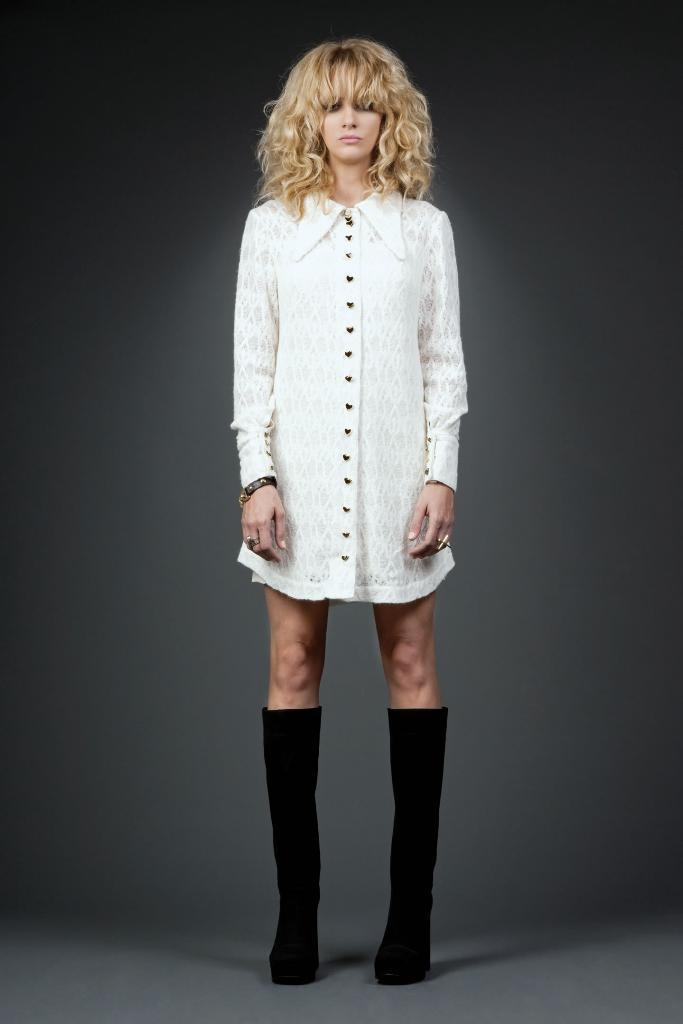Who is the main subject in the image? There is a lady in the image. What color is the background of the image? The background of the image is gray in color. What type of field does the lady regret not having experience in? There is no field mentioned in the image, nor is there any indication of regret or experience. 